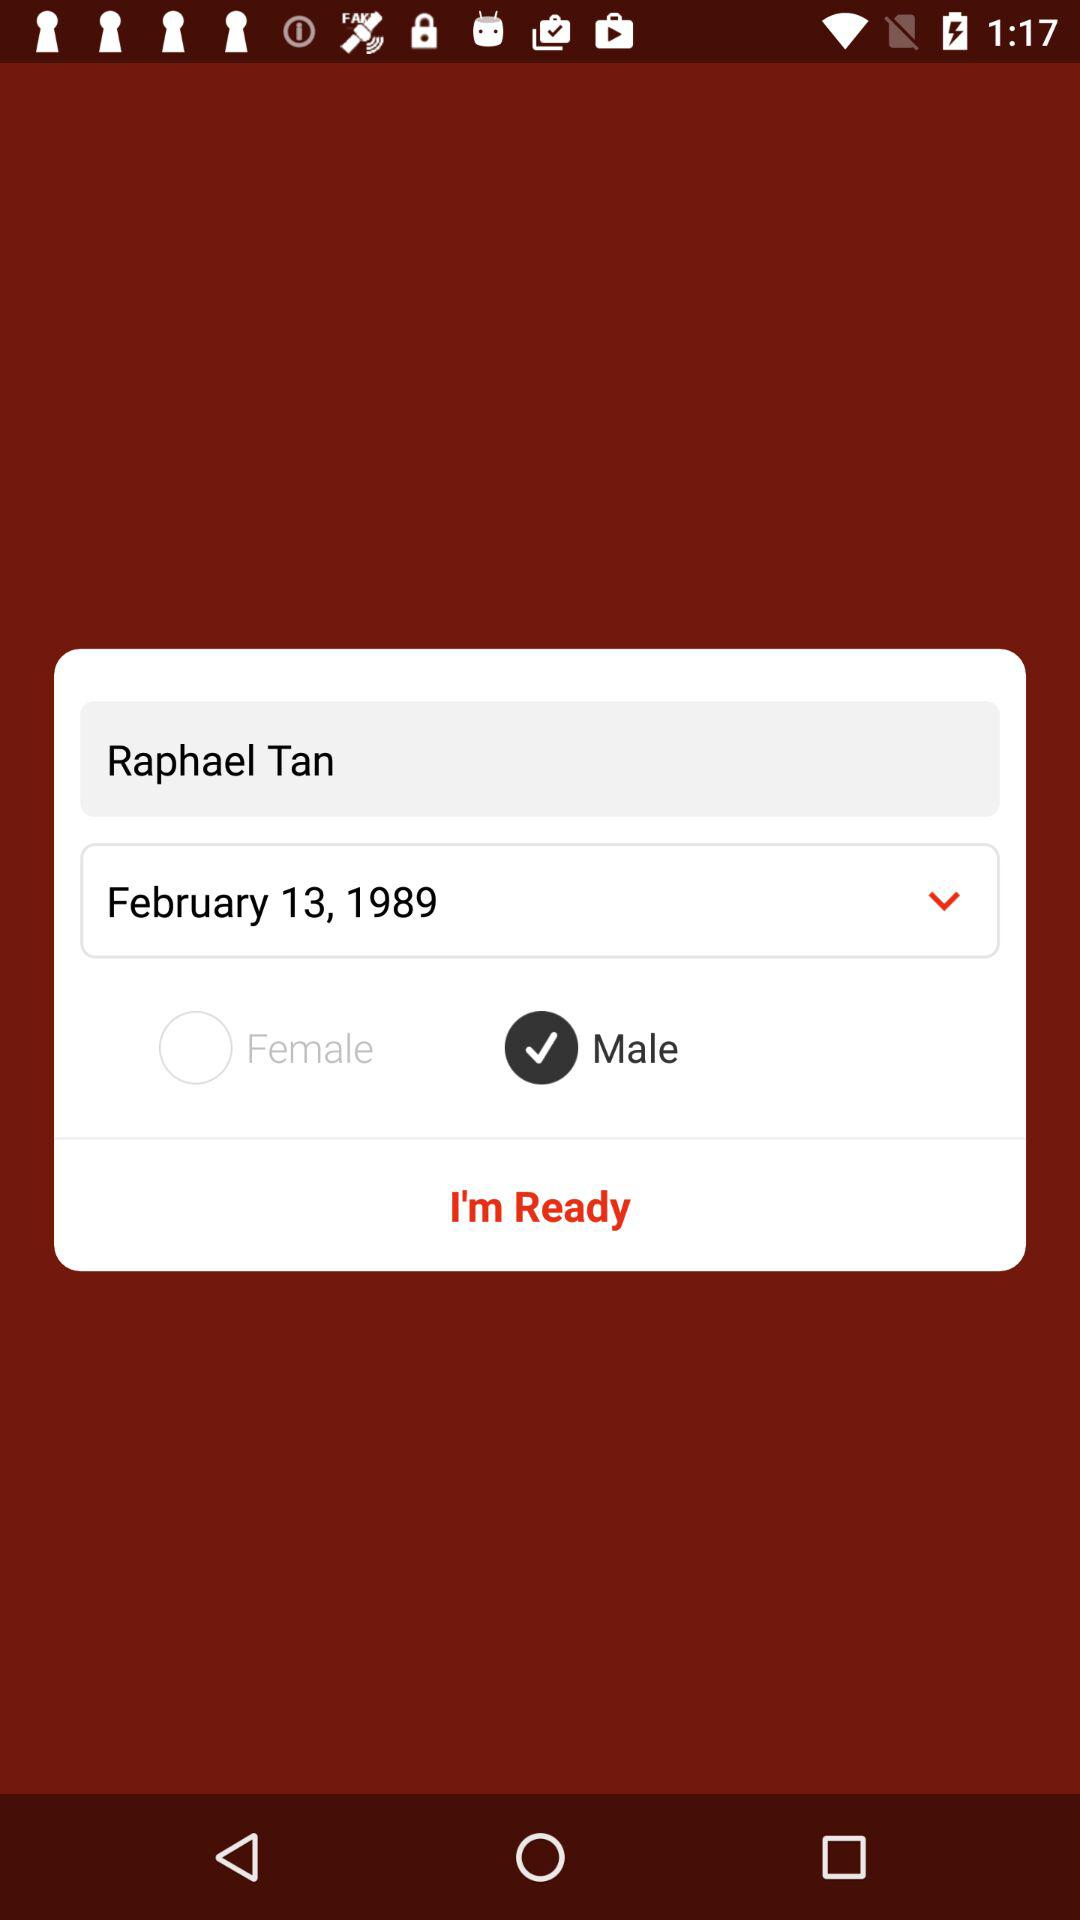What is the name of the user? The name of the user is Raphael Tan. 